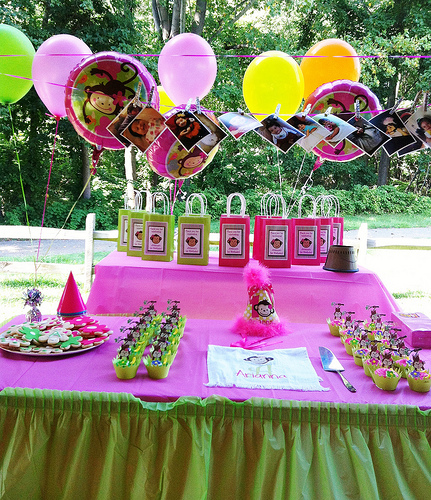<image>
Is the baloon above the table? Yes. The baloon is positioned above the table in the vertical space, higher up in the scene. 